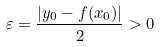Convert formula to latex. <formula><loc_0><loc_0><loc_500><loc_500>\varepsilon = { \frac { | y _ { 0 } - f ( x _ { 0 } ) | } { 2 } } > 0</formula> 